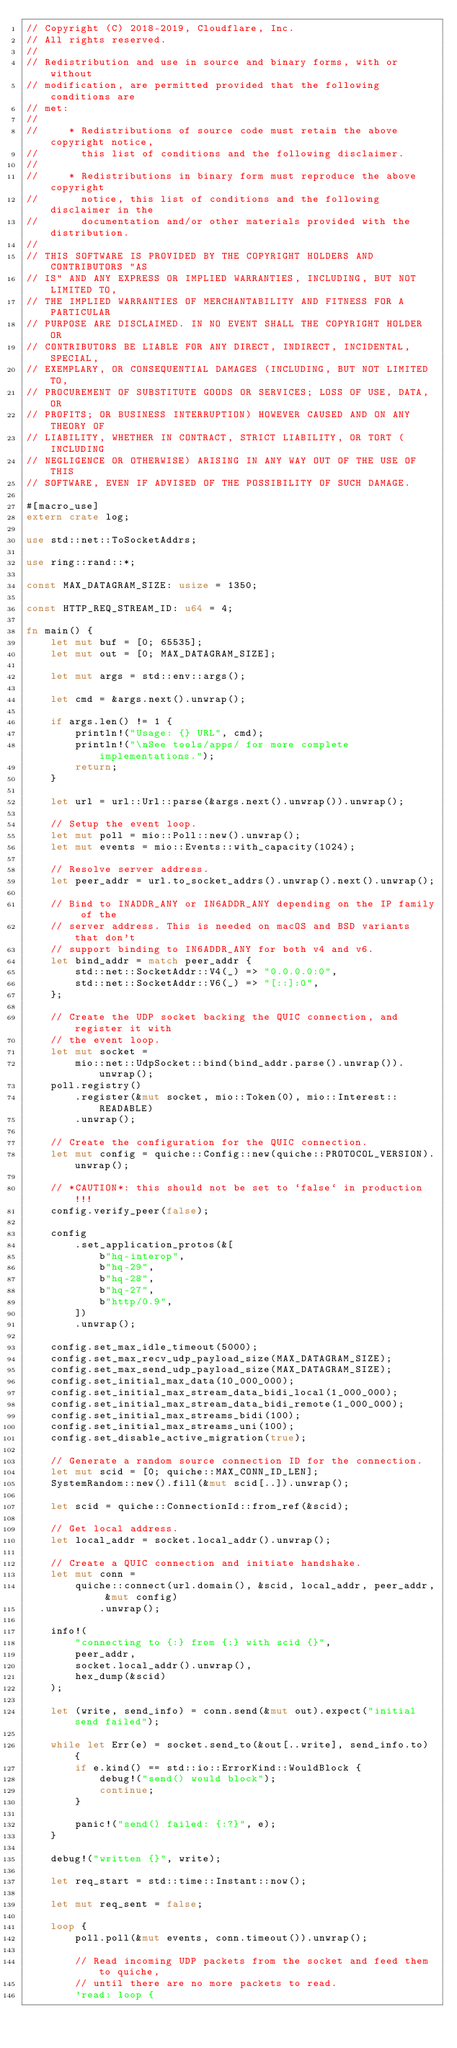Convert code to text. <code><loc_0><loc_0><loc_500><loc_500><_Rust_>// Copyright (C) 2018-2019, Cloudflare, Inc.
// All rights reserved.
//
// Redistribution and use in source and binary forms, with or without
// modification, are permitted provided that the following conditions are
// met:
//
//     * Redistributions of source code must retain the above copyright notice,
//       this list of conditions and the following disclaimer.
//
//     * Redistributions in binary form must reproduce the above copyright
//       notice, this list of conditions and the following disclaimer in the
//       documentation and/or other materials provided with the distribution.
//
// THIS SOFTWARE IS PROVIDED BY THE COPYRIGHT HOLDERS AND CONTRIBUTORS "AS
// IS" AND ANY EXPRESS OR IMPLIED WARRANTIES, INCLUDING, BUT NOT LIMITED TO,
// THE IMPLIED WARRANTIES OF MERCHANTABILITY AND FITNESS FOR A PARTICULAR
// PURPOSE ARE DISCLAIMED. IN NO EVENT SHALL THE COPYRIGHT HOLDER OR
// CONTRIBUTORS BE LIABLE FOR ANY DIRECT, INDIRECT, INCIDENTAL, SPECIAL,
// EXEMPLARY, OR CONSEQUENTIAL DAMAGES (INCLUDING, BUT NOT LIMITED TO,
// PROCUREMENT OF SUBSTITUTE GOODS OR SERVICES; LOSS OF USE, DATA, OR
// PROFITS; OR BUSINESS INTERRUPTION) HOWEVER CAUSED AND ON ANY THEORY OF
// LIABILITY, WHETHER IN CONTRACT, STRICT LIABILITY, OR TORT (INCLUDING
// NEGLIGENCE OR OTHERWISE) ARISING IN ANY WAY OUT OF THE USE OF THIS
// SOFTWARE, EVEN IF ADVISED OF THE POSSIBILITY OF SUCH DAMAGE.

#[macro_use]
extern crate log;

use std::net::ToSocketAddrs;

use ring::rand::*;

const MAX_DATAGRAM_SIZE: usize = 1350;

const HTTP_REQ_STREAM_ID: u64 = 4;

fn main() {
    let mut buf = [0; 65535];
    let mut out = [0; MAX_DATAGRAM_SIZE];

    let mut args = std::env::args();

    let cmd = &args.next().unwrap();

    if args.len() != 1 {
        println!("Usage: {} URL", cmd);
        println!("\nSee tools/apps/ for more complete implementations.");
        return;
    }

    let url = url::Url::parse(&args.next().unwrap()).unwrap();

    // Setup the event loop.
    let mut poll = mio::Poll::new().unwrap();
    let mut events = mio::Events::with_capacity(1024);

    // Resolve server address.
    let peer_addr = url.to_socket_addrs().unwrap().next().unwrap();

    // Bind to INADDR_ANY or IN6ADDR_ANY depending on the IP family of the
    // server address. This is needed on macOS and BSD variants that don't
    // support binding to IN6ADDR_ANY for both v4 and v6.
    let bind_addr = match peer_addr {
        std::net::SocketAddr::V4(_) => "0.0.0.0:0",
        std::net::SocketAddr::V6(_) => "[::]:0",
    };

    // Create the UDP socket backing the QUIC connection, and register it with
    // the event loop.
    let mut socket =
        mio::net::UdpSocket::bind(bind_addr.parse().unwrap()).unwrap();
    poll.registry()
        .register(&mut socket, mio::Token(0), mio::Interest::READABLE)
        .unwrap();

    // Create the configuration for the QUIC connection.
    let mut config = quiche::Config::new(quiche::PROTOCOL_VERSION).unwrap();

    // *CAUTION*: this should not be set to `false` in production!!!
    config.verify_peer(false);

    config
        .set_application_protos(&[
            b"hq-interop",
            b"hq-29",
            b"hq-28",
            b"hq-27",
            b"http/0.9",
        ])
        .unwrap();

    config.set_max_idle_timeout(5000);
    config.set_max_recv_udp_payload_size(MAX_DATAGRAM_SIZE);
    config.set_max_send_udp_payload_size(MAX_DATAGRAM_SIZE);
    config.set_initial_max_data(10_000_000);
    config.set_initial_max_stream_data_bidi_local(1_000_000);
    config.set_initial_max_stream_data_bidi_remote(1_000_000);
    config.set_initial_max_streams_bidi(100);
    config.set_initial_max_streams_uni(100);
    config.set_disable_active_migration(true);

    // Generate a random source connection ID for the connection.
    let mut scid = [0; quiche::MAX_CONN_ID_LEN];
    SystemRandom::new().fill(&mut scid[..]).unwrap();

    let scid = quiche::ConnectionId::from_ref(&scid);

    // Get local address.
    let local_addr = socket.local_addr().unwrap();

    // Create a QUIC connection and initiate handshake.
    let mut conn =
        quiche::connect(url.domain(), &scid, local_addr, peer_addr, &mut config)
            .unwrap();

    info!(
        "connecting to {:} from {:} with scid {}",
        peer_addr,
        socket.local_addr().unwrap(),
        hex_dump(&scid)
    );

    let (write, send_info) = conn.send(&mut out).expect("initial send failed");

    while let Err(e) = socket.send_to(&out[..write], send_info.to) {
        if e.kind() == std::io::ErrorKind::WouldBlock {
            debug!("send() would block");
            continue;
        }

        panic!("send() failed: {:?}", e);
    }

    debug!("written {}", write);

    let req_start = std::time::Instant::now();

    let mut req_sent = false;

    loop {
        poll.poll(&mut events, conn.timeout()).unwrap();

        // Read incoming UDP packets from the socket and feed them to quiche,
        // until there are no more packets to read.
        'read: loop {</code> 